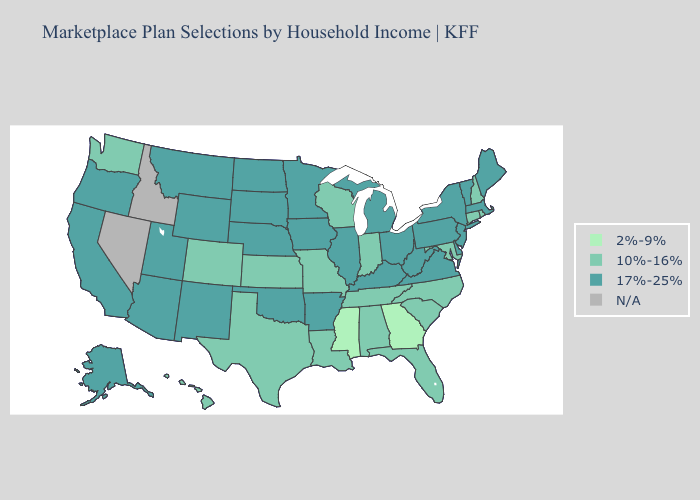Does the map have missing data?
Concise answer only. Yes. What is the lowest value in states that border Idaho?
Quick response, please. 10%-16%. Does Kentucky have the lowest value in the South?
Quick response, please. No. What is the value of Kentucky?
Be succinct. 17%-25%. What is the value of Connecticut?
Be succinct. 10%-16%. How many symbols are there in the legend?
Write a very short answer. 4. What is the lowest value in states that border Pennsylvania?
Concise answer only. 10%-16%. Name the states that have a value in the range 10%-16%?
Be succinct. Alabama, Colorado, Connecticut, Florida, Hawaii, Indiana, Kansas, Louisiana, Maryland, Missouri, New Hampshire, North Carolina, Rhode Island, South Carolina, Tennessee, Texas, Washington, Wisconsin. Among the states that border Massachusetts , which have the lowest value?
Quick response, please. Connecticut, New Hampshire, Rhode Island. What is the highest value in states that border North Carolina?
Write a very short answer. 17%-25%. Which states have the highest value in the USA?
Concise answer only. Alaska, Arizona, Arkansas, California, Delaware, Illinois, Iowa, Kentucky, Maine, Massachusetts, Michigan, Minnesota, Montana, Nebraska, New Jersey, New Mexico, New York, North Dakota, Ohio, Oklahoma, Oregon, Pennsylvania, South Dakota, Utah, Vermont, Virginia, West Virginia, Wyoming. Does Georgia have the lowest value in the USA?
Quick response, please. Yes. What is the value of Montana?
Short answer required. 17%-25%. Among the states that border Oregon , which have the lowest value?
Be succinct. Washington. What is the value of Texas?
Write a very short answer. 10%-16%. 